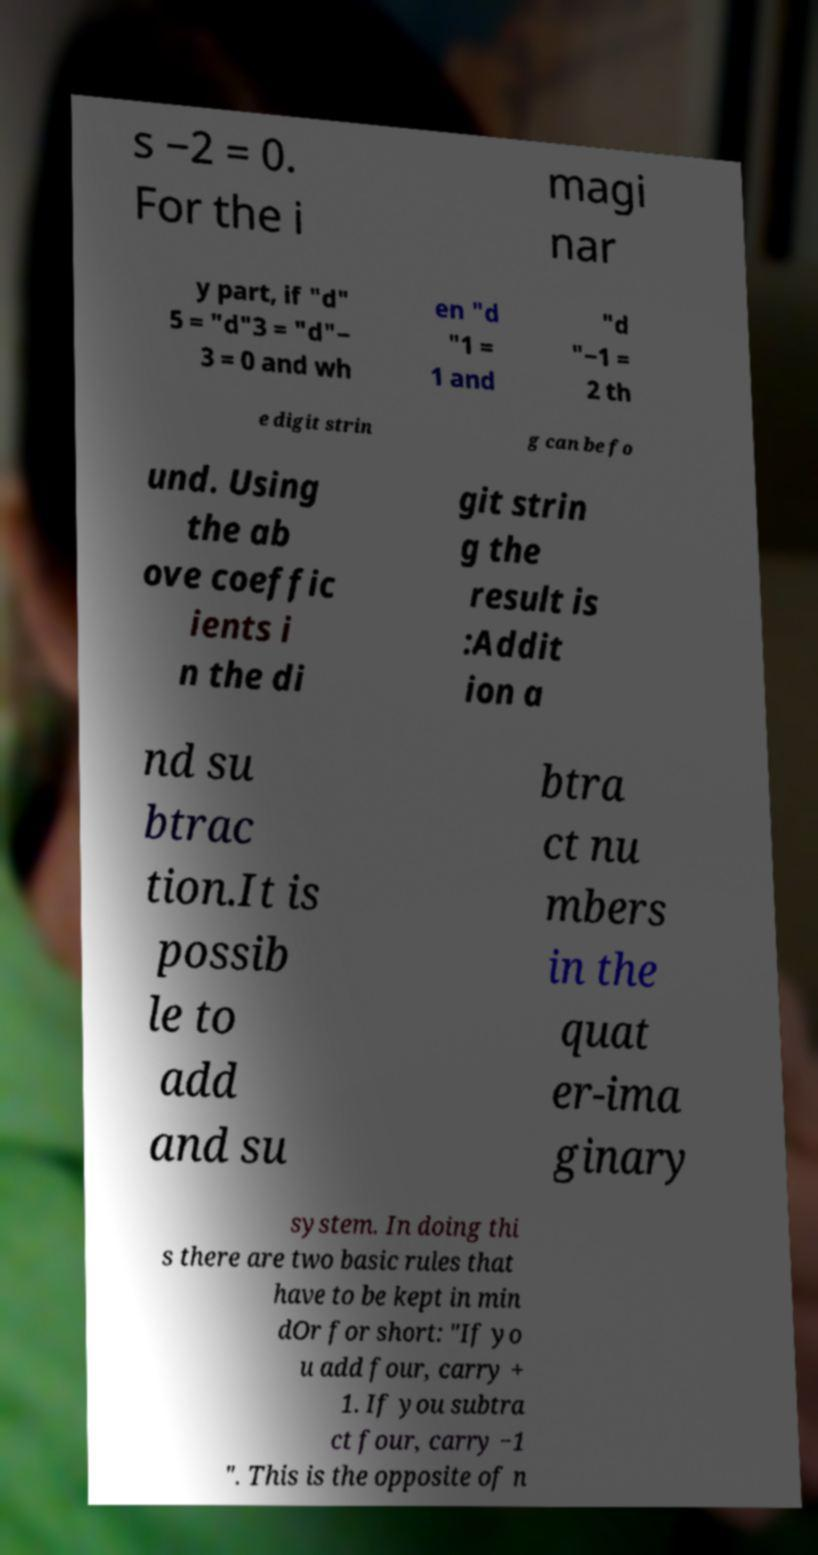For documentation purposes, I need the text within this image transcribed. Could you provide that? s −2 = 0. For the i magi nar y part, if "d" 5 = "d"3 = "d"− 3 = 0 and wh en "d "1 = 1 and "d "−1 = 2 th e digit strin g can be fo und. Using the ab ove coeffic ients i n the di git strin g the result is :Addit ion a nd su btrac tion.It is possib le to add and su btra ct nu mbers in the quat er-ima ginary system. In doing thi s there are two basic rules that have to be kept in min dOr for short: "If yo u add four, carry + 1. If you subtra ct four, carry −1 ". This is the opposite of n 